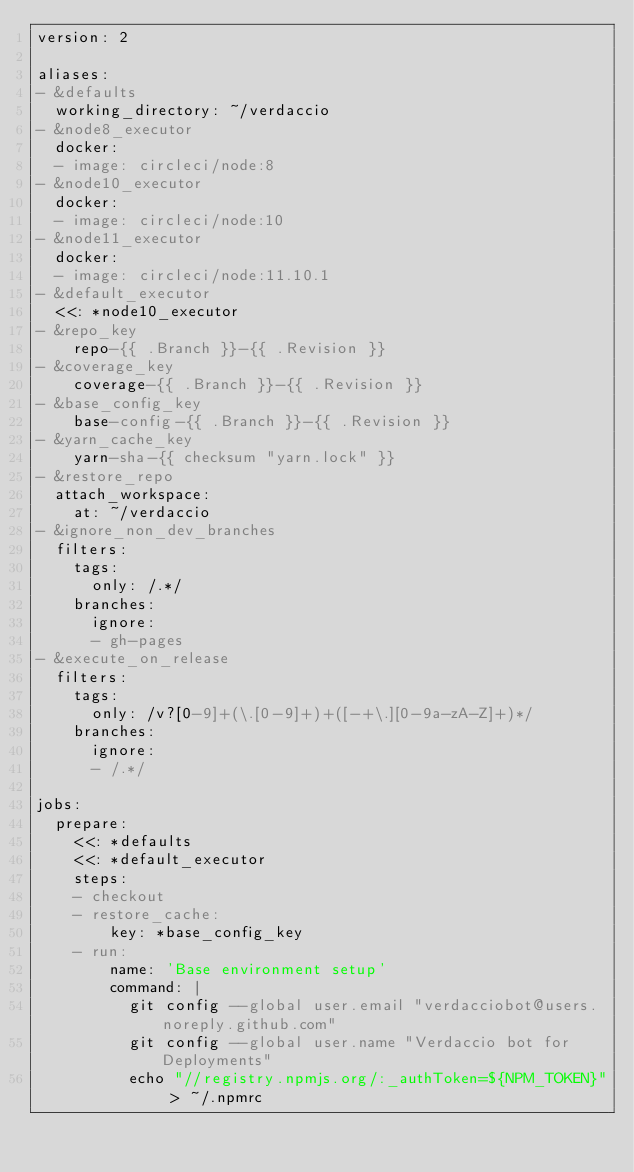<code> <loc_0><loc_0><loc_500><loc_500><_YAML_>version: 2

aliases:
- &defaults
  working_directory: ~/verdaccio
- &node8_executor
  docker:
  - image: circleci/node:8
- &node10_executor
  docker:
  - image: circleci/node:10
- &node11_executor
  docker:
  - image: circleci/node:11.10.1
- &default_executor
  <<: *node10_executor
- &repo_key
    repo-{{ .Branch }}-{{ .Revision }}
- &coverage_key
    coverage-{{ .Branch }}-{{ .Revision }}
- &base_config_key
    base-config-{{ .Branch }}-{{ .Revision }}
- &yarn_cache_key
    yarn-sha-{{ checksum "yarn.lock" }}
- &restore_repo
  attach_workspace:
    at: ~/verdaccio
- &ignore_non_dev_branches
  filters:
    tags:
      only: /.*/
    branches:
      ignore:
      - gh-pages
- &execute_on_release
  filters:
    tags:
      only: /v?[0-9]+(\.[0-9]+)+([-+\.][0-9a-zA-Z]+)*/
    branches:
      ignore:
      - /.*/

jobs:
  prepare:
    <<: *defaults
    <<: *default_executor
    steps:
    - checkout
    - restore_cache:
        key: *base_config_key
    - run:
        name: 'Base environment setup'
        command: |
          git config --global user.email "verdacciobot@users.noreply.github.com"
          git config --global user.name "Verdaccio bot for Deployments"
          echo "//registry.npmjs.org/:_authToken=${NPM_TOKEN}" > ~/.npmrc</code> 